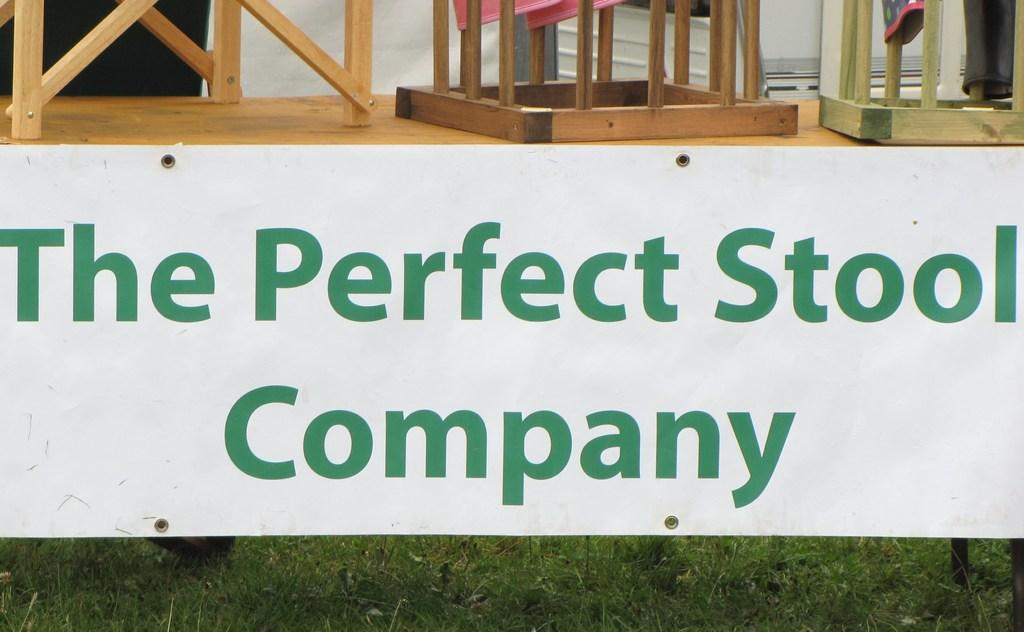What type of image is being described? The image is a banner. What can be seen on the wooden platform in the image? There are stools on the wooden platform. What is the color of the grass visible at the bottom portion of the image? The grass is green. What type of net is being used to catch the representative in the image? There is no net or representative present in the image. 